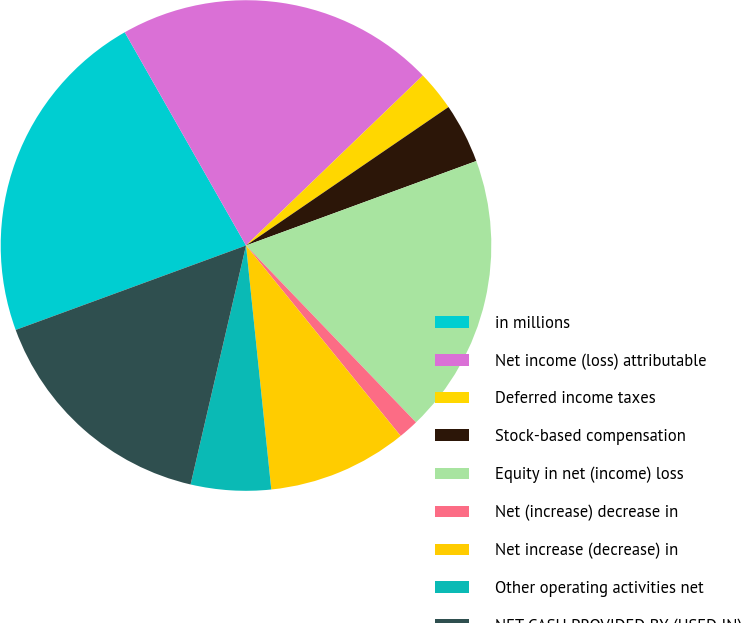Convert chart. <chart><loc_0><loc_0><loc_500><loc_500><pie_chart><fcel>in millions<fcel>Net income (loss) attributable<fcel>Deferred income taxes<fcel>Stock-based compensation<fcel>Equity in net (income) loss<fcel>Net (increase) decrease in<fcel>Net increase (decrease) in<fcel>Other operating activities net<fcel>NET CASH PROVIDED BY (USED IN)<nl><fcel>22.36%<fcel>21.04%<fcel>2.64%<fcel>3.95%<fcel>18.41%<fcel>1.33%<fcel>9.21%<fcel>5.27%<fcel>15.78%<nl></chart> 